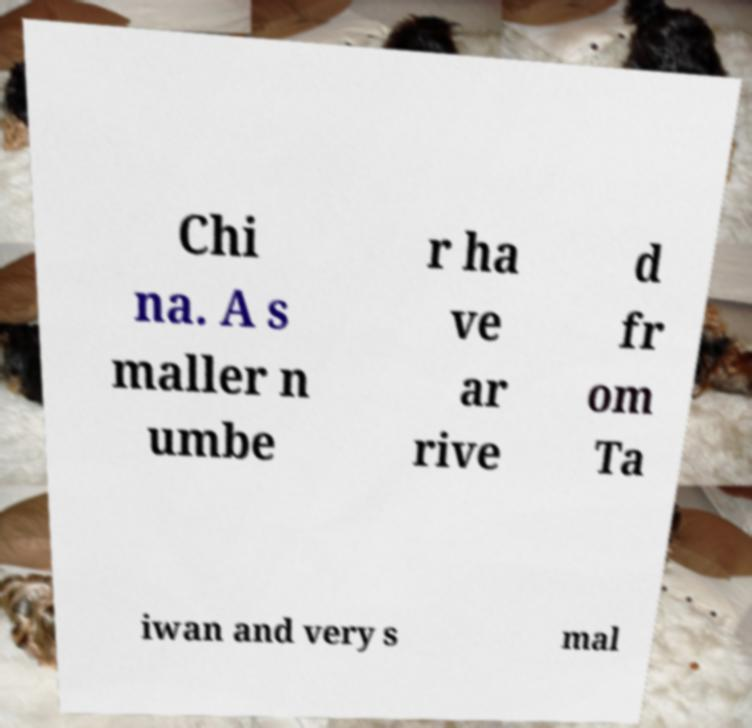Can you read and provide the text displayed in the image?This photo seems to have some interesting text. Can you extract and type it out for me? Chi na. A s maller n umbe r ha ve ar rive d fr om Ta iwan and very s mal 